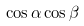Convert formula to latex. <formula><loc_0><loc_0><loc_500><loc_500>\cos \alpha \cos \beta</formula> 